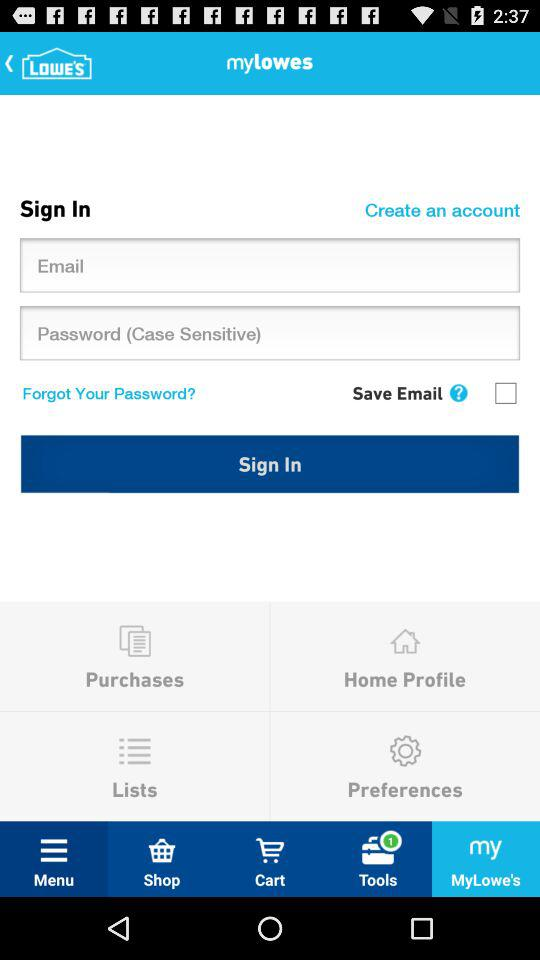What is the name of application? The name of application is "Lowe's". 